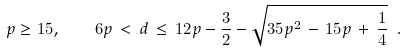<formula> <loc_0><loc_0><loc_500><loc_500>p \geq 1 5 , \quad 6 p \, < \, d \, \leq \, 1 2 p - \frac { 3 } { 2 } - \sqrt { 3 5 p ^ { 2 } \, - \, 1 5 p \, + \, \frac { 1 } { 4 } } \ .</formula> 